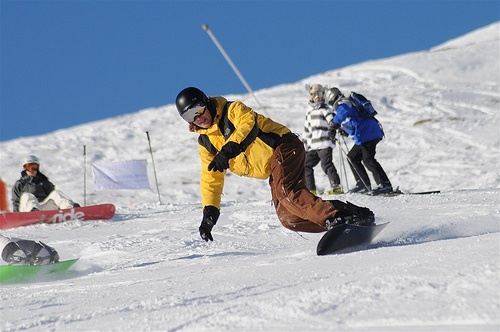Describe the objects in this image and their specific colors. I can see people in gray, black, olive, maroon, and orange tones, people in gray, black, navy, and darkgray tones, people in gray, black, lightgray, and darkgray tones, people in gray, black, lightgray, and darkgray tones, and snowboard in gray, brown, darkgray, and lightgray tones in this image. 